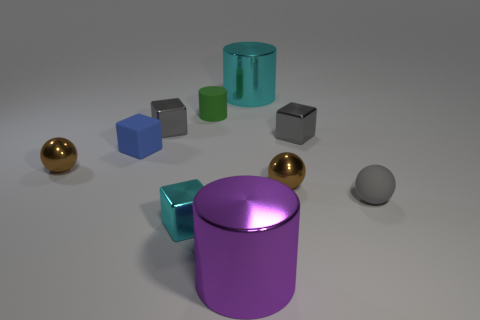What number of objects are either tiny green objects or big shiny cylinders in front of the tiny green matte cylinder?
Offer a terse response. 2. What is the material of the cyan block?
Ensure brevity in your answer.  Metal. Is there anything else that is the same color as the matte block?
Provide a short and direct response. No. Do the purple metallic object and the small blue object have the same shape?
Offer a terse response. No. What size is the gray shiny thing that is to the left of the tiny gray metal cube that is to the right of the small shiny ball that is right of the purple cylinder?
Give a very brief answer. Small. What number of other things are there of the same material as the small cyan thing
Offer a very short reply. 6. There is a tiny matte thing right of the large cyan thing; what color is it?
Give a very brief answer. Gray. There is a big cylinder that is in front of the gray thing in front of the gray cube right of the purple thing; what is its material?
Ensure brevity in your answer.  Metal. Is there a large metal thing of the same shape as the tiny cyan metallic object?
Offer a terse response. No. What is the shape of the cyan thing that is the same size as the purple metal object?
Provide a short and direct response. Cylinder. 